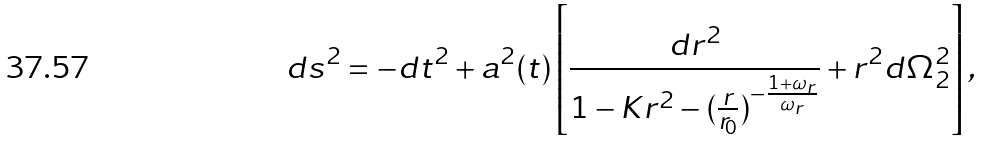<formula> <loc_0><loc_0><loc_500><loc_500>d s ^ { 2 } = - d t ^ { 2 } + a ^ { 2 } ( t ) \left [ \frac { d r ^ { 2 } } { 1 - K r ^ { 2 } - ( \frac { r } { r _ { 0 } } ) ^ { - \frac { 1 + \omega _ { r } } { \omega _ { r } } } } + r ^ { 2 } d \Omega _ { 2 } ^ { 2 } \right ] ,</formula> 